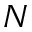<formula> <loc_0><loc_0><loc_500><loc_500>N</formula> 